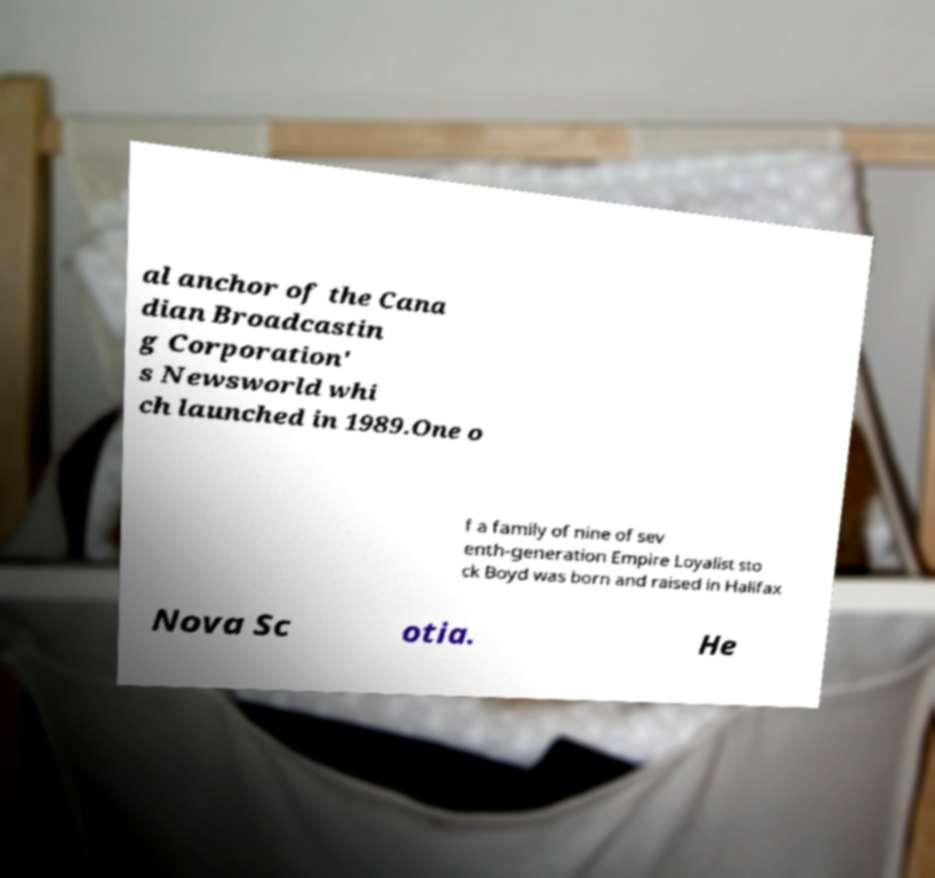I need the written content from this picture converted into text. Can you do that? al anchor of the Cana dian Broadcastin g Corporation' s Newsworld whi ch launched in 1989.One o f a family of nine of sev enth-generation Empire Loyalist sto ck Boyd was born and raised in Halifax Nova Sc otia. He 